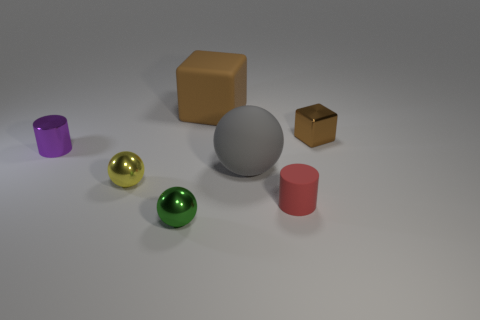Add 3 green balls. How many objects exist? 10 Subtract all blocks. How many objects are left? 5 Add 1 red cylinders. How many red cylinders exist? 2 Subtract 0 cyan balls. How many objects are left? 7 Subtract all cylinders. Subtract all small purple shiny cylinders. How many objects are left? 4 Add 3 tiny green spheres. How many tiny green spheres are left? 4 